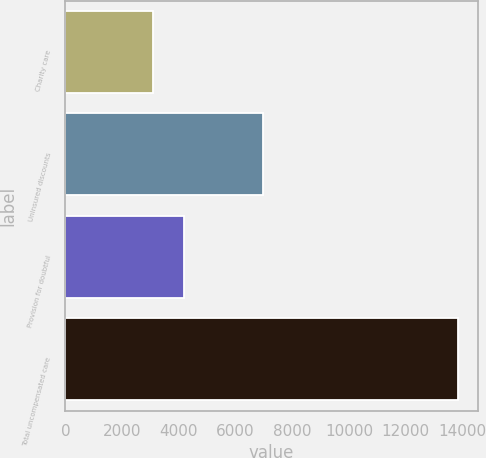<chart> <loc_0><loc_0><loc_500><loc_500><bar_chart><fcel>Charity care<fcel>Uninsured discounts<fcel>Provision for doubtful<fcel>Total uncompensated care<nl><fcel>3093<fcel>6978<fcel>4167.8<fcel>13841<nl></chart> 